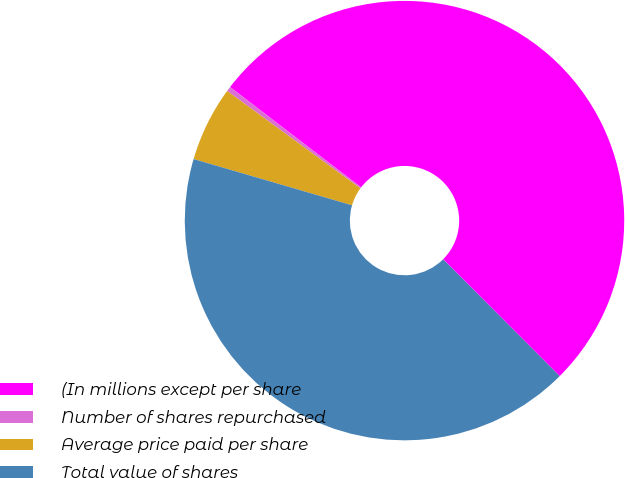Convert chart. <chart><loc_0><loc_0><loc_500><loc_500><pie_chart><fcel>(In millions except per share<fcel>Number of shares repurchased<fcel>Average price paid per share<fcel>Total value of shares<nl><fcel>52.12%<fcel>0.35%<fcel>5.53%<fcel>42.0%<nl></chart> 